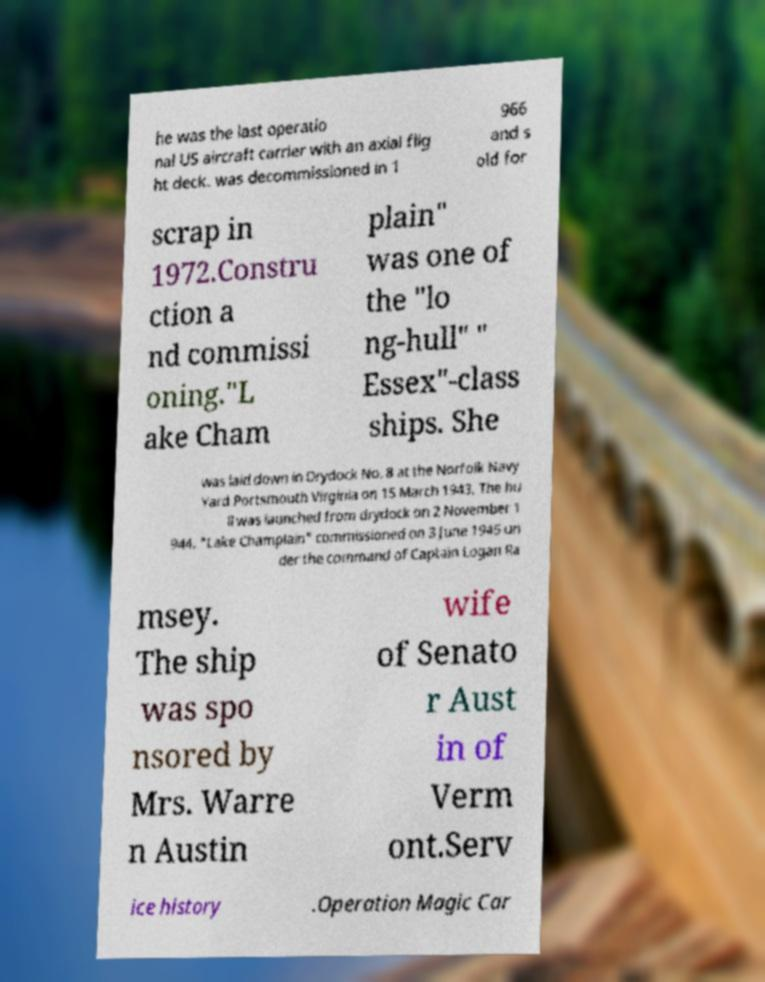I need the written content from this picture converted into text. Can you do that? he was the last operatio nal US aircraft carrier with an axial flig ht deck. was decommissioned in 1 966 and s old for scrap in 1972.Constru ction a nd commissi oning."L ake Cham plain" was one of the "lo ng-hull" " Essex"-class ships. She was laid down in Drydock No. 8 at the Norfolk Navy Yard Portsmouth Virginia on 15 March 1943. The hu ll was launched from drydock on 2 November 1 944. "Lake Champlain" commissioned on 3 June 1945 un der the command of Captain Logan Ra msey. The ship was spo nsored by Mrs. Warre n Austin wife of Senato r Aust in of Verm ont.Serv ice history .Operation Magic Car 